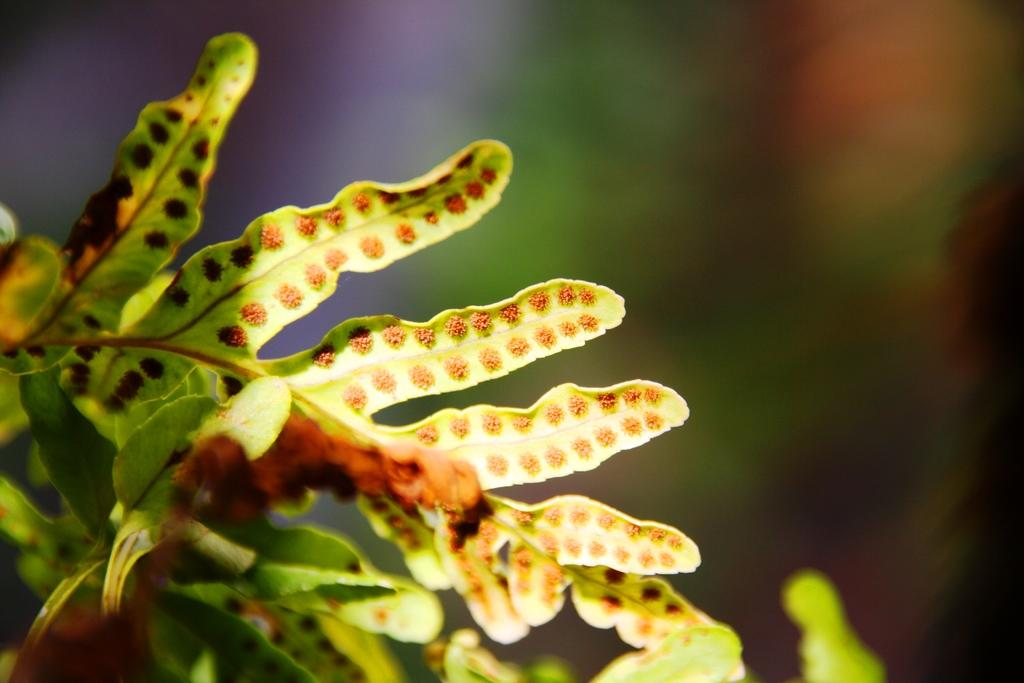What type of vegetation can be seen in the image? There are leaves in the image. Can you describe the background of the image? The background of the image is blurry. What type of border can be seen surrounding the sea in the image? There is no sea or border present in the image; it only contains leaves and a blurry background. 